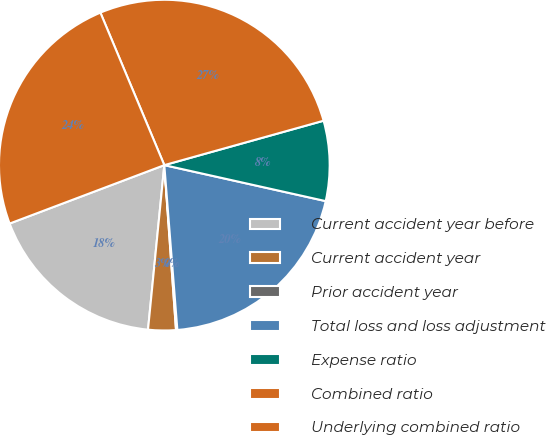Convert chart to OTSL. <chart><loc_0><loc_0><loc_500><loc_500><pie_chart><fcel>Current accident year before<fcel>Current accident year<fcel>Prior accident year<fcel>Total loss and loss adjustment<fcel>Expense ratio<fcel>Combined ratio<fcel>Underlying combined ratio<nl><fcel>17.68%<fcel>2.7%<fcel>0.13%<fcel>20.25%<fcel>7.82%<fcel>26.99%<fcel>24.43%<nl></chart> 